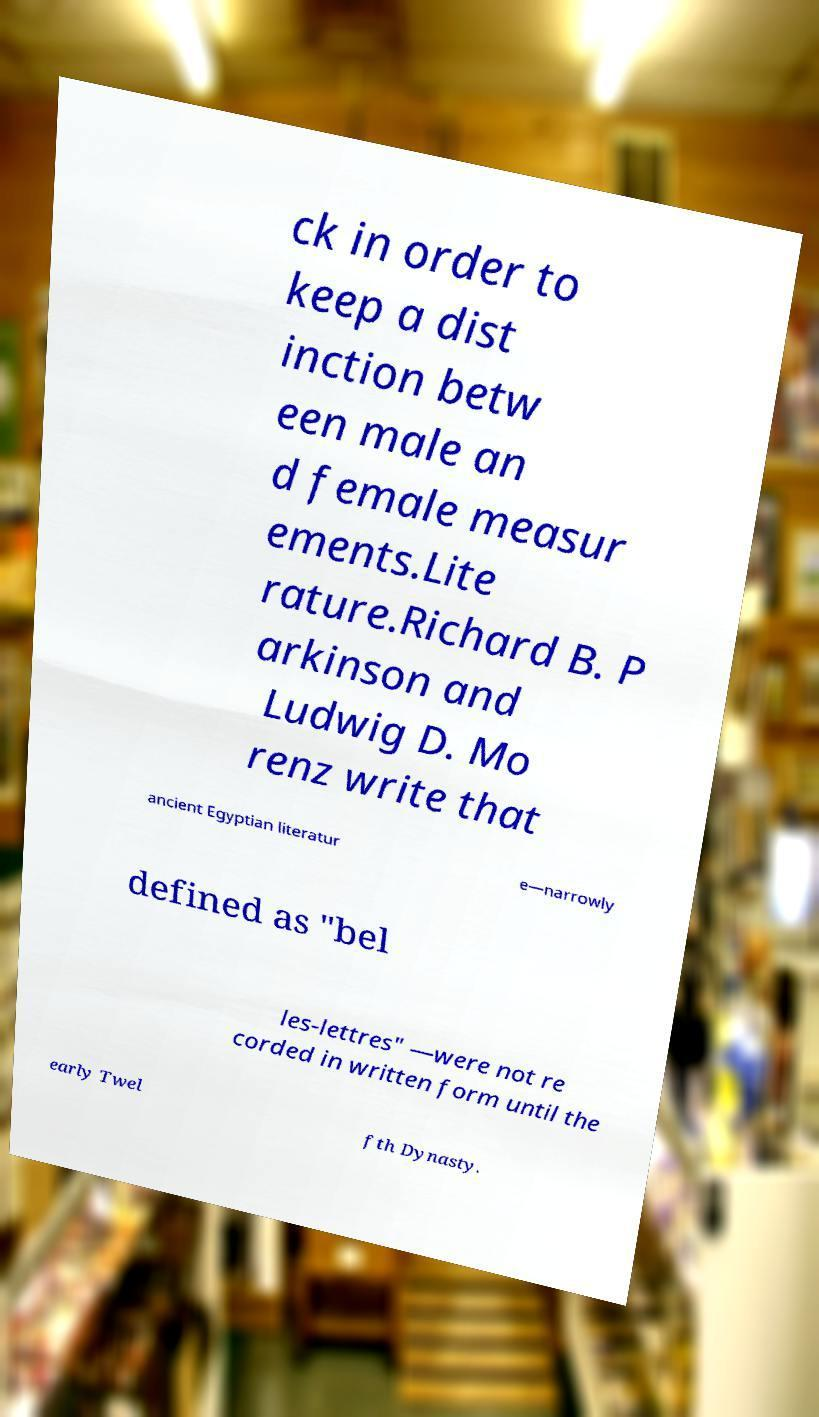Please read and relay the text visible in this image. What does it say? ck in order to keep a dist inction betw een male an d female measur ements.Lite rature.Richard B. P arkinson and Ludwig D. Mo renz write that ancient Egyptian literatur e—narrowly defined as "bel les-lettres" —were not re corded in written form until the early Twel fth Dynasty. 